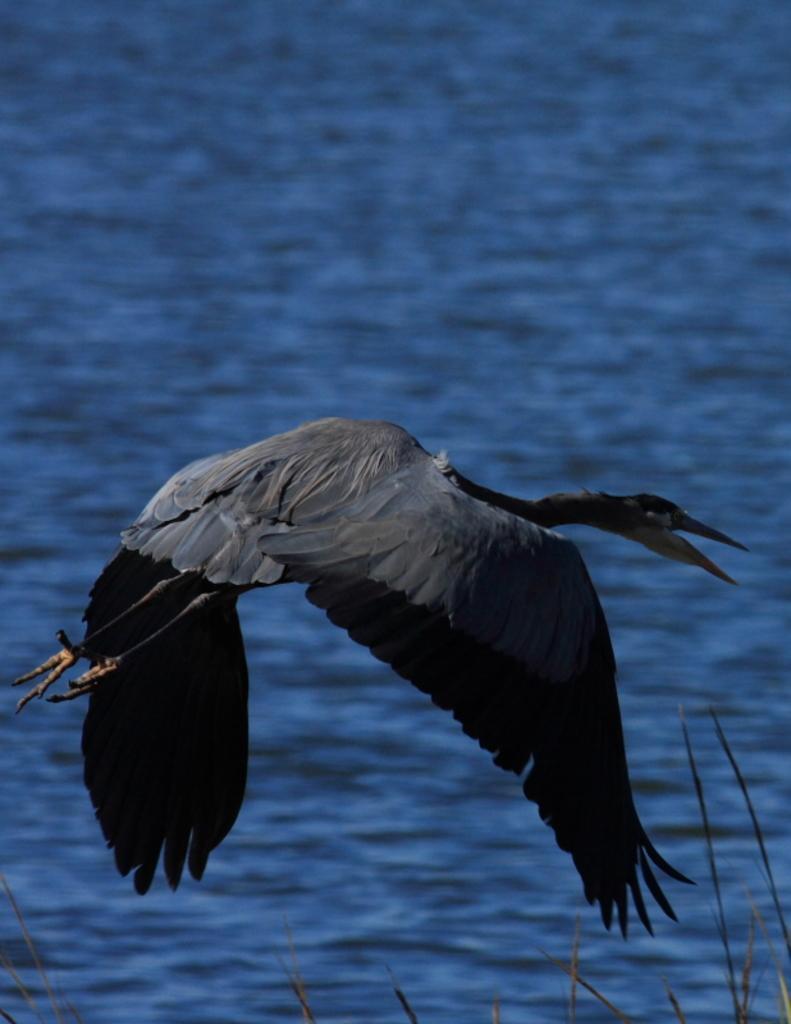How would you summarize this image in a sentence or two? In this image we can see a bird is flying and it is black in color. In the background of the image we can see water body. 